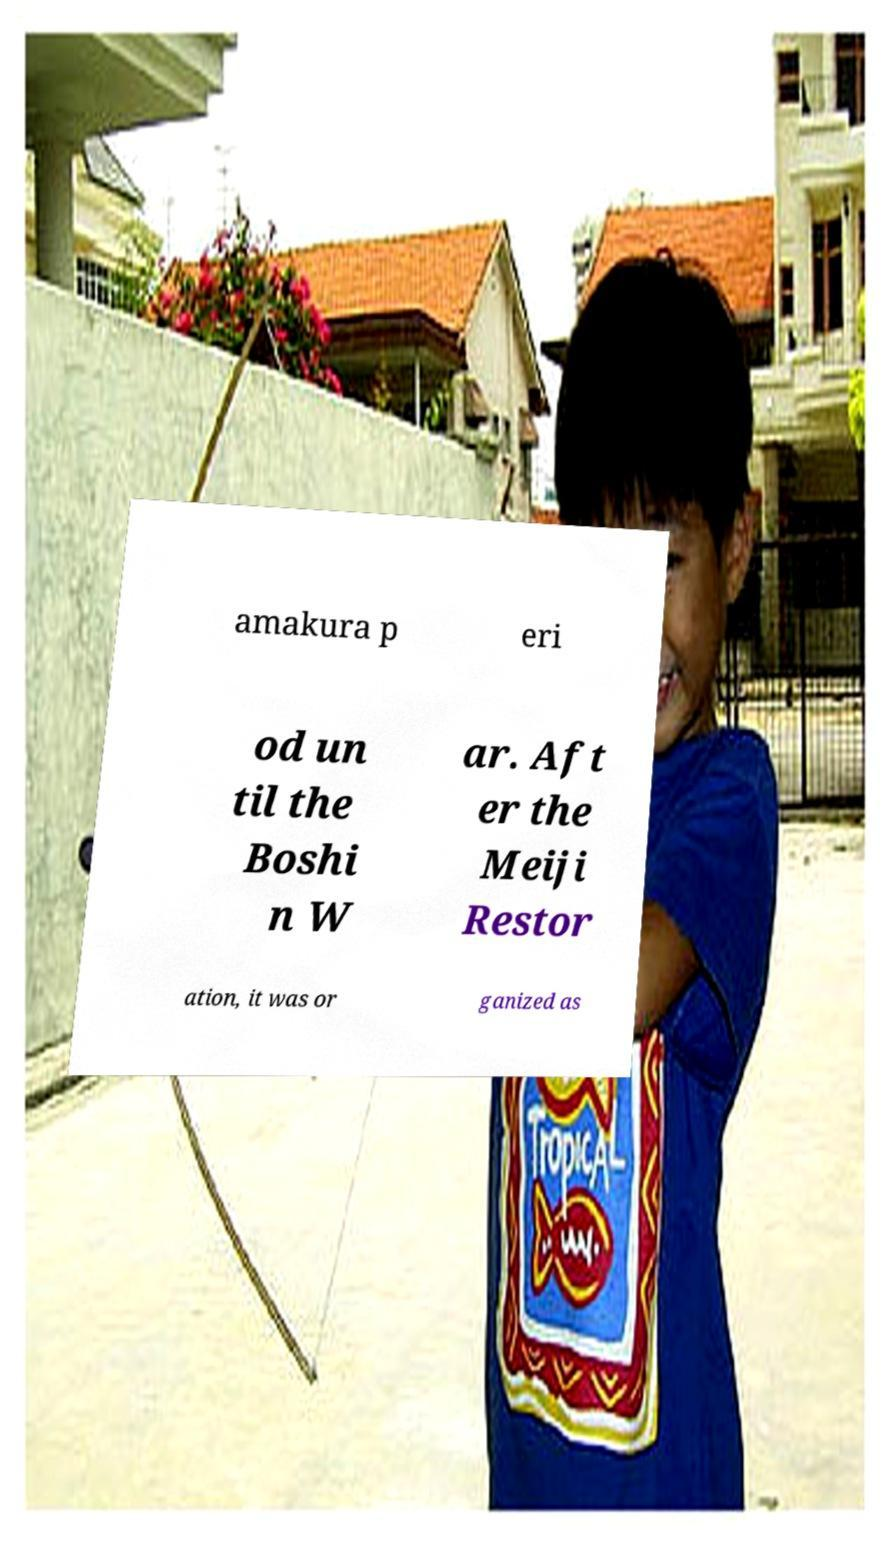Can you accurately transcribe the text from the provided image for me? amakura p eri od un til the Boshi n W ar. Aft er the Meiji Restor ation, it was or ganized as 